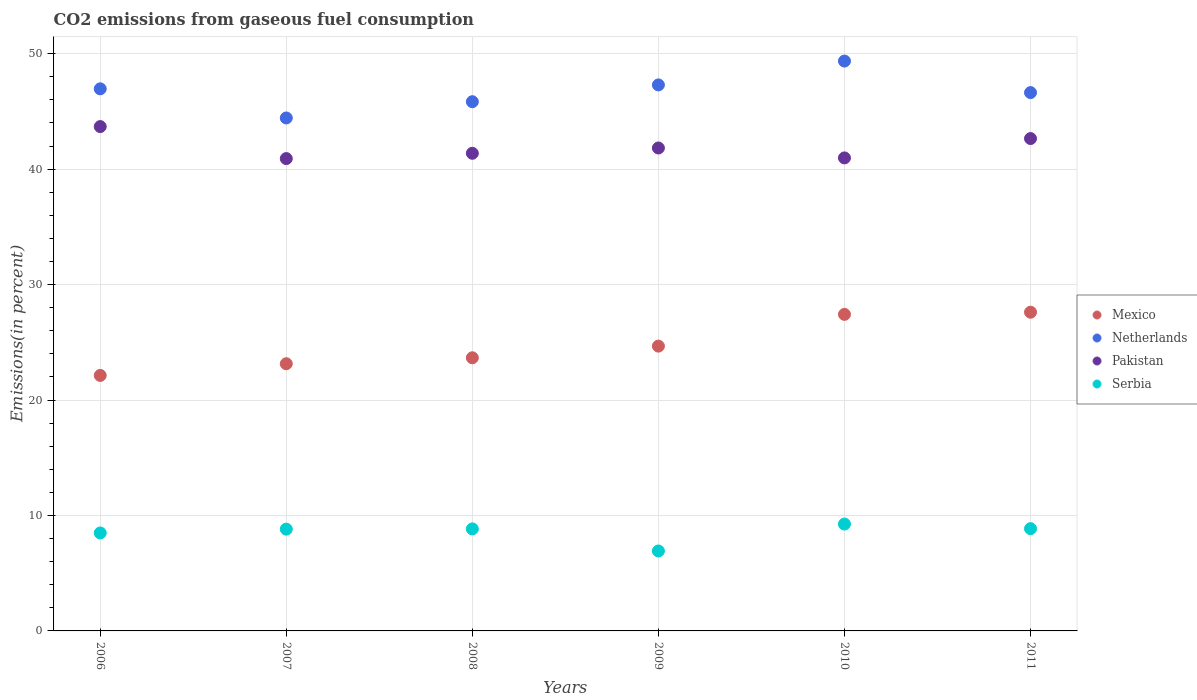How many different coloured dotlines are there?
Give a very brief answer. 4. Is the number of dotlines equal to the number of legend labels?
Ensure brevity in your answer.  Yes. What is the total CO2 emitted in Mexico in 2010?
Provide a short and direct response. 27.42. Across all years, what is the maximum total CO2 emitted in Serbia?
Your answer should be very brief. 9.26. Across all years, what is the minimum total CO2 emitted in Serbia?
Your answer should be compact. 6.92. What is the total total CO2 emitted in Netherlands in the graph?
Make the answer very short. 280.49. What is the difference between the total CO2 emitted in Mexico in 2007 and that in 2009?
Give a very brief answer. -1.53. What is the difference between the total CO2 emitted in Netherlands in 2006 and the total CO2 emitted in Serbia in 2008?
Keep it short and to the point. 38.12. What is the average total CO2 emitted in Netherlands per year?
Your answer should be very brief. 46.75. In the year 2008, what is the difference between the total CO2 emitted in Mexico and total CO2 emitted in Pakistan?
Make the answer very short. -17.71. What is the ratio of the total CO2 emitted in Netherlands in 2007 to that in 2008?
Provide a short and direct response. 0.97. Is the total CO2 emitted in Mexico in 2010 less than that in 2011?
Make the answer very short. Yes. Is the difference between the total CO2 emitted in Mexico in 2009 and 2011 greater than the difference between the total CO2 emitted in Pakistan in 2009 and 2011?
Provide a succinct answer. No. What is the difference between the highest and the second highest total CO2 emitted in Serbia?
Keep it short and to the point. 0.4. What is the difference between the highest and the lowest total CO2 emitted in Pakistan?
Offer a terse response. 2.77. Is it the case that in every year, the sum of the total CO2 emitted in Mexico and total CO2 emitted in Pakistan  is greater than the sum of total CO2 emitted in Netherlands and total CO2 emitted in Serbia?
Offer a very short reply. No. Is it the case that in every year, the sum of the total CO2 emitted in Pakistan and total CO2 emitted in Netherlands  is greater than the total CO2 emitted in Mexico?
Offer a terse response. Yes. Is the total CO2 emitted in Netherlands strictly greater than the total CO2 emitted in Pakistan over the years?
Ensure brevity in your answer.  Yes. Is the total CO2 emitted in Mexico strictly less than the total CO2 emitted in Pakistan over the years?
Your response must be concise. Yes. How many years are there in the graph?
Your answer should be compact. 6. Are the values on the major ticks of Y-axis written in scientific E-notation?
Provide a succinct answer. No. Does the graph contain any zero values?
Keep it short and to the point. No. Does the graph contain grids?
Your response must be concise. Yes. Where does the legend appear in the graph?
Offer a terse response. Center right. How many legend labels are there?
Offer a very short reply. 4. What is the title of the graph?
Your answer should be compact. CO2 emissions from gaseous fuel consumption. What is the label or title of the X-axis?
Provide a succinct answer. Years. What is the label or title of the Y-axis?
Give a very brief answer. Emissions(in percent). What is the Emissions(in percent) in Mexico in 2006?
Make the answer very short. 22.13. What is the Emissions(in percent) of Netherlands in 2006?
Your answer should be compact. 46.95. What is the Emissions(in percent) in Pakistan in 2006?
Your answer should be very brief. 43.68. What is the Emissions(in percent) in Serbia in 2006?
Your answer should be very brief. 8.48. What is the Emissions(in percent) of Mexico in 2007?
Keep it short and to the point. 23.14. What is the Emissions(in percent) in Netherlands in 2007?
Offer a very short reply. 44.43. What is the Emissions(in percent) of Pakistan in 2007?
Your answer should be very brief. 40.91. What is the Emissions(in percent) of Serbia in 2007?
Provide a short and direct response. 8.81. What is the Emissions(in percent) in Mexico in 2008?
Ensure brevity in your answer.  23.66. What is the Emissions(in percent) in Netherlands in 2008?
Provide a succinct answer. 45.84. What is the Emissions(in percent) in Pakistan in 2008?
Keep it short and to the point. 41.37. What is the Emissions(in percent) in Serbia in 2008?
Provide a succinct answer. 8.84. What is the Emissions(in percent) of Mexico in 2009?
Ensure brevity in your answer.  24.67. What is the Emissions(in percent) in Netherlands in 2009?
Keep it short and to the point. 47.29. What is the Emissions(in percent) of Pakistan in 2009?
Ensure brevity in your answer.  41.83. What is the Emissions(in percent) of Serbia in 2009?
Ensure brevity in your answer.  6.92. What is the Emissions(in percent) in Mexico in 2010?
Offer a terse response. 27.42. What is the Emissions(in percent) in Netherlands in 2010?
Make the answer very short. 49.36. What is the Emissions(in percent) in Pakistan in 2010?
Provide a short and direct response. 40.97. What is the Emissions(in percent) of Serbia in 2010?
Keep it short and to the point. 9.26. What is the Emissions(in percent) of Mexico in 2011?
Provide a short and direct response. 27.61. What is the Emissions(in percent) in Netherlands in 2011?
Ensure brevity in your answer.  46.63. What is the Emissions(in percent) of Pakistan in 2011?
Your answer should be very brief. 42.65. What is the Emissions(in percent) in Serbia in 2011?
Your answer should be compact. 8.86. Across all years, what is the maximum Emissions(in percent) in Mexico?
Offer a terse response. 27.61. Across all years, what is the maximum Emissions(in percent) of Netherlands?
Keep it short and to the point. 49.36. Across all years, what is the maximum Emissions(in percent) in Pakistan?
Provide a succinct answer. 43.68. Across all years, what is the maximum Emissions(in percent) in Serbia?
Provide a short and direct response. 9.26. Across all years, what is the minimum Emissions(in percent) in Mexico?
Offer a terse response. 22.13. Across all years, what is the minimum Emissions(in percent) in Netherlands?
Offer a very short reply. 44.43. Across all years, what is the minimum Emissions(in percent) of Pakistan?
Give a very brief answer. 40.91. Across all years, what is the minimum Emissions(in percent) of Serbia?
Offer a terse response. 6.92. What is the total Emissions(in percent) in Mexico in the graph?
Provide a short and direct response. 148.62. What is the total Emissions(in percent) in Netherlands in the graph?
Give a very brief answer. 280.49. What is the total Emissions(in percent) of Pakistan in the graph?
Your response must be concise. 251.41. What is the total Emissions(in percent) of Serbia in the graph?
Give a very brief answer. 51.17. What is the difference between the Emissions(in percent) in Mexico in 2006 and that in 2007?
Ensure brevity in your answer.  -1.01. What is the difference between the Emissions(in percent) of Netherlands in 2006 and that in 2007?
Make the answer very short. 2.52. What is the difference between the Emissions(in percent) in Pakistan in 2006 and that in 2007?
Provide a succinct answer. 2.77. What is the difference between the Emissions(in percent) in Serbia in 2006 and that in 2007?
Your answer should be compact. -0.33. What is the difference between the Emissions(in percent) of Mexico in 2006 and that in 2008?
Your response must be concise. -1.53. What is the difference between the Emissions(in percent) in Netherlands in 2006 and that in 2008?
Your response must be concise. 1.12. What is the difference between the Emissions(in percent) of Pakistan in 2006 and that in 2008?
Your answer should be compact. 2.31. What is the difference between the Emissions(in percent) in Serbia in 2006 and that in 2008?
Make the answer very short. -0.35. What is the difference between the Emissions(in percent) of Mexico in 2006 and that in 2009?
Your response must be concise. -2.54. What is the difference between the Emissions(in percent) in Netherlands in 2006 and that in 2009?
Your answer should be very brief. -0.34. What is the difference between the Emissions(in percent) of Pakistan in 2006 and that in 2009?
Keep it short and to the point. 1.85. What is the difference between the Emissions(in percent) of Serbia in 2006 and that in 2009?
Keep it short and to the point. 1.56. What is the difference between the Emissions(in percent) in Mexico in 2006 and that in 2010?
Make the answer very short. -5.29. What is the difference between the Emissions(in percent) of Netherlands in 2006 and that in 2010?
Your answer should be compact. -2.4. What is the difference between the Emissions(in percent) of Pakistan in 2006 and that in 2010?
Provide a succinct answer. 2.71. What is the difference between the Emissions(in percent) of Serbia in 2006 and that in 2010?
Provide a short and direct response. -0.77. What is the difference between the Emissions(in percent) in Mexico in 2006 and that in 2011?
Your answer should be compact. -5.48. What is the difference between the Emissions(in percent) in Netherlands in 2006 and that in 2011?
Your answer should be very brief. 0.33. What is the difference between the Emissions(in percent) of Pakistan in 2006 and that in 2011?
Your answer should be very brief. 1.04. What is the difference between the Emissions(in percent) of Serbia in 2006 and that in 2011?
Ensure brevity in your answer.  -0.37. What is the difference between the Emissions(in percent) in Mexico in 2007 and that in 2008?
Provide a short and direct response. -0.52. What is the difference between the Emissions(in percent) of Netherlands in 2007 and that in 2008?
Provide a succinct answer. -1.41. What is the difference between the Emissions(in percent) of Pakistan in 2007 and that in 2008?
Provide a succinct answer. -0.46. What is the difference between the Emissions(in percent) of Serbia in 2007 and that in 2008?
Your answer should be very brief. -0.02. What is the difference between the Emissions(in percent) of Mexico in 2007 and that in 2009?
Make the answer very short. -1.53. What is the difference between the Emissions(in percent) in Netherlands in 2007 and that in 2009?
Keep it short and to the point. -2.86. What is the difference between the Emissions(in percent) in Pakistan in 2007 and that in 2009?
Your response must be concise. -0.92. What is the difference between the Emissions(in percent) in Serbia in 2007 and that in 2009?
Ensure brevity in your answer.  1.89. What is the difference between the Emissions(in percent) of Mexico in 2007 and that in 2010?
Provide a short and direct response. -4.28. What is the difference between the Emissions(in percent) in Netherlands in 2007 and that in 2010?
Your response must be concise. -4.93. What is the difference between the Emissions(in percent) of Pakistan in 2007 and that in 2010?
Give a very brief answer. -0.06. What is the difference between the Emissions(in percent) in Serbia in 2007 and that in 2010?
Provide a succinct answer. -0.44. What is the difference between the Emissions(in percent) in Mexico in 2007 and that in 2011?
Keep it short and to the point. -4.46. What is the difference between the Emissions(in percent) in Netherlands in 2007 and that in 2011?
Make the answer very short. -2.2. What is the difference between the Emissions(in percent) of Pakistan in 2007 and that in 2011?
Your answer should be compact. -1.74. What is the difference between the Emissions(in percent) in Serbia in 2007 and that in 2011?
Offer a terse response. -0.04. What is the difference between the Emissions(in percent) in Mexico in 2008 and that in 2009?
Offer a terse response. -1.01. What is the difference between the Emissions(in percent) of Netherlands in 2008 and that in 2009?
Offer a very short reply. -1.45. What is the difference between the Emissions(in percent) of Pakistan in 2008 and that in 2009?
Offer a terse response. -0.46. What is the difference between the Emissions(in percent) in Serbia in 2008 and that in 2009?
Your response must be concise. 1.91. What is the difference between the Emissions(in percent) in Mexico in 2008 and that in 2010?
Your answer should be compact. -3.76. What is the difference between the Emissions(in percent) of Netherlands in 2008 and that in 2010?
Your response must be concise. -3.52. What is the difference between the Emissions(in percent) of Pakistan in 2008 and that in 2010?
Your answer should be very brief. 0.4. What is the difference between the Emissions(in percent) in Serbia in 2008 and that in 2010?
Provide a succinct answer. -0.42. What is the difference between the Emissions(in percent) of Mexico in 2008 and that in 2011?
Your response must be concise. -3.95. What is the difference between the Emissions(in percent) of Netherlands in 2008 and that in 2011?
Ensure brevity in your answer.  -0.79. What is the difference between the Emissions(in percent) of Pakistan in 2008 and that in 2011?
Your answer should be very brief. -1.28. What is the difference between the Emissions(in percent) in Serbia in 2008 and that in 2011?
Offer a very short reply. -0.02. What is the difference between the Emissions(in percent) of Mexico in 2009 and that in 2010?
Your answer should be very brief. -2.75. What is the difference between the Emissions(in percent) in Netherlands in 2009 and that in 2010?
Make the answer very short. -2.07. What is the difference between the Emissions(in percent) of Pakistan in 2009 and that in 2010?
Provide a short and direct response. 0.86. What is the difference between the Emissions(in percent) of Serbia in 2009 and that in 2010?
Your response must be concise. -2.33. What is the difference between the Emissions(in percent) in Mexico in 2009 and that in 2011?
Your response must be concise. -2.94. What is the difference between the Emissions(in percent) in Netherlands in 2009 and that in 2011?
Your response must be concise. 0.67. What is the difference between the Emissions(in percent) in Pakistan in 2009 and that in 2011?
Ensure brevity in your answer.  -0.82. What is the difference between the Emissions(in percent) in Serbia in 2009 and that in 2011?
Provide a short and direct response. -1.93. What is the difference between the Emissions(in percent) in Mexico in 2010 and that in 2011?
Give a very brief answer. -0.19. What is the difference between the Emissions(in percent) in Netherlands in 2010 and that in 2011?
Keep it short and to the point. 2.73. What is the difference between the Emissions(in percent) of Pakistan in 2010 and that in 2011?
Ensure brevity in your answer.  -1.68. What is the difference between the Emissions(in percent) in Serbia in 2010 and that in 2011?
Offer a very short reply. 0.4. What is the difference between the Emissions(in percent) of Mexico in 2006 and the Emissions(in percent) of Netherlands in 2007?
Offer a terse response. -22.3. What is the difference between the Emissions(in percent) in Mexico in 2006 and the Emissions(in percent) in Pakistan in 2007?
Your answer should be very brief. -18.78. What is the difference between the Emissions(in percent) of Mexico in 2006 and the Emissions(in percent) of Serbia in 2007?
Provide a short and direct response. 13.31. What is the difference between the Emissions(in percent) of Netherlands in 2006 and the Emissions(in percent) of Pakistan in 2007?
Your answer should be very brief. 6.04. What is the difference between the Emissions(in percent) of Netherlands in 2006 and the Emissions(in percent) of Serbia in 2007?
Ensure brevity in your answer.  38.14. What is the difference between the Emissions(in percent) of Pakistan in 2006 and the Emissions(in percent) of Serbia in 2007?
Your answer should be compact. 34.87. What is the difference between the Emissions(in percent) in Mexico in 2006 and the Emissions(in percent) in Netherlands in 2008?
Offer a very short reply. -23.71. What is the difference between the Emissions(in percent) of Mexico in 2006 and the Emissions(in percent) of Pakistan in 2008?
Provide a succinct answer. -19.24. What is the difference between the Emissions(in percent) in Mexico in 2006 and the Emissions(in percent) in Serbia in 2008?
Provide a succinct answer. 13.29. What is the difference between the Emissions(in percent) in Netherlands in 2006 and the Emissions(in percent) in Pakistan in 2008?
Ensure brevity in your answer.  5.58. What is the difference between the Emissions(in percent) in Netherlands in 2006 and the Emissions(in percent) in Serbia in 2008?
Offer a terse response. 38.12. What is the difference between the Emissions(in percent) in Pakistan in 2006 and the Emissions(in percent) in Serbia in 2008?
Offer a terse response. 34.85. What is the difference between the Emissions(in percent) in Mexico in 2006 and the Emissions(in percent) in Netherlands in 2009?
Ensure brevity in your answer.  -25.16. What is the difference between the Emissions(in percent) of Mexico in 2006 and the Emissions(in percent) of Pakistan in 2009?
Offer a terse response. -19.7. What is the difference between the Emissions(in percent) of Mexico in 2006 and the Emissions(in percent) of Serbia in 2009?
Your answer should be compact. 15.2. What is the difference between the Emissions(in percent) of Netherlands in 2006 and the Emissions(in percent) of Pakistan in 2009?
Provide a succinct answer. 5.13. What is the difference between the Emissions(in percent) of Netherlands in 2006 and the Emissions(in percent) of Serbia in 2009?
Your answer should be very brief. 40.03. What is the difference between the Emissions(in percent) in Pakistan in 2006 and the Emissions(in percent) in Serbia in 2009?
Your answer should be very brief. 36.76. What is the difference between the Emissions(in percent) of Mexico in 2006 and the Emissions(in percent) of Netherlands in 2010?
Ensure brevity in your answer.  -27.23. What is the difference between the Emissions(in percent) in Mexico in 2006 and the Emissions(in percent) in Pakistan in 2010?
Make the answer very short. -18.84. What is the difference between the Emissions(in percent) in Mexico in 2006 and the Emissions(in percent) in Serbia in 2010?
Make the answer very short. 12.87. What is the difference between the Emissions(in percent) in Netherlands in 2006 and the Emissions(in percent) in Pakistan in 2010?
Provide a succinct answer. 5.98. What is the difference between the Emissions(in percent) of Netherlands in 2006 and the Emissions(in percent) of Serbia in 2010?
Give a very brief answer. 37.7. What is the difference between the Emissions(in percent) in Pakistan in 2006 and the Emissions(in percent) in Serbia in 2010?
Offer a very short reply. 34.43. What is the difference between the Emissions(in percent) in Mexico in 2006 and the Emissions(in percent) in Netherlands in 2011?
Offer a very short reply. -24.5. What is the difference between the Emissions(in percent) in Mexico in 2006 and the Emissions(in percent) in Pakistan in 2011?
Provide a short and direct response. -20.52. What is the difference between the Emissions(in percent) in Mexico in 2006 and the Emissions(in percent) in Serbia in 2011?
Give a very brief answer. 13.27. What is the difference between the Emissions(in percent) in Netherlands in 2006 and the Emissions(in percent) in Pakistan in 2011?
Offer a terse response. 4.31. What is the difference between the Emissions(in percent) of Netherlands in 2006 and the Emissions(in percent) of Serbia in 2011?
Give a very brief answer. 38.1. What is the difference between the Emissions(in percent) in Pakistan in 2006 and the Emissions(in percent) in Serbia in 2011?
Provide a short and direct response. 34.83. What is the difference between the Emissions(in percent) of Mexico in 2007 and the Emissions(in percent) of Netherlands in 2008?
Provide a succinct answer. -22.7. What is the difference between the Emissions(in percent) of Mexico in 2007 and the Emissions(in percent) of Pakistan in 2008?
Your answer should be compact. -18.23. What is the difference between the Emissions(in percent) of Mexico in 2007 and the Emissions(in percent) of Serbia in 2008?
Keep it short and to the point. 14.31. What is the difference between the Emissions(in percent) in Netherlands in 2007 and the Emissions(in percent) in Pakistan in 2008?
Provide a short and direct response. 3.06. What is the difference between the Emissions(in percent) of Netherlands in 2007 and the Emissions(in percent) of Serbia in 2008?
Your response must be concise. 35.59. What is the difference between the Emissions(in percent) of Pakistan in 2007 and the Emissions(in percent) of Serbia in 2008?
Offer a very short reply. 32.08. What is the difference between the Emissions(in percent) of Mexico in 2007 and the Emissions(in percent) of Netherlands in 2009?
Provide a succinct answer. -24.15. What is the difference between the Emissions(in percent) in Mexico in 2007 and the Emissions(in percent) in Pakistan in 2009?
Keep it short and to the point. -18.69. What is the difference between the Emissions(in percent) in Mexico in 2007 and the Emissions(in percent) in Serbia in 2009?
Make the answer very short. 16.22. What is the difference between the Emissions(in percent) of Netherlands in 2007 and the Emissions(in percent) of Pakistan in 2009?
Your answer should be very brief. 2.6. What is the difference between the Emissions(in percent) in Netherlands in 2007 and the Emissions(in percent) in Serbia in 2009?
Provide a succinct answer. 37.51. What is the difference between the Emissions(in percent) in Pakistan in 2007 and the Emissions(in percent) in Serbia in 2009?
Offer a very short reply. 33.99. What is the difference between the Emissions(in percent) in Mexico in 2007 and the Emissions(in percent) in Netherlands in 2010?
Your answer should be very brief. -26.22. What is the difference between the Emissions(in percent) of Mexico in 2007 and the Emissions(in percent) of Pakistan in 2010?
Keep it short and to the point. -17.83. What is the difference between the Emissions(in percent) in Mexico in 2007 and the Emissions(in percent) in Serbia in 2010?
Offer a terse response. 13.89. What is the difference between the Emissions(in percent) in Netherlands in 2007 and the Emissions(in percent) in Pakistan in 2010?
Offer a very short reply. 3.46. What is the difference between the Emissions(in percent) in Netherlands in 2007 and the Emissions(in percent) in Serbia in 2010?
Keep it short and to the point. 35.17. What is the difference between the Emissions(in percent) of Pakistan in 2007 and the Emissions(in percent) of Serbia in 2010?
Provide a succinct answer. 31.65. What is the difference between the Emissions(in percent) in Mexico in 2007 and the Emissions(in percent) in Netherlands in 2011?
Provide a succinct answer. -23.48. What is the difference between the Emissions(in percent) in Mexico in 2007 and the Emissions(in percent) in Pakistan in 2011?
Keep it short and to the point. -19.5. What is the difference between the Emissions(in percent) in Mexico in 2007 and the Emissions(in percent) in Serbia in 2011?
Offer a terse response. 14.28. What is the difference between the Emissions(in percent) of Netherlands in 2007 and the Emissions(in percent) of Pakistan in 2011?
Your answer should be compact. 1.78. What is the difference between the Emissions(in percent) in Netherlands in 2007 and the Emissions(in percent) in Serbia in 2011?
Keep it short and to the point. 35.57. What is the difference between the Emissions(in percent) of Pakistan in 2007 and the Emissions(in percent) of Serbia in 2011?
Make the answer very short. 32.05. What is the difference between the Emissions(in percent) of Mexico in 2008 and the Emissions(in percent) of Netherlands in 2009?
Make the answer very short. -23.63. What is the difference between the Emissions(in percent) of Mexico in 2008 and the Emissions(in percent) of Pakistan in 2009?
Provide a short and direct response. -18.17. What is the difference between the Emissions(in percent) in Mexico in 2008 and the Emissions(in percent) in Serbia in 2009?
Make the answer very short. 16.73. What is the difference between the Emissions(in percent) of Netherlands in 2008 and the Emissions(in percent) of Pakistan in 2009?
Keep it short and to the point. 4.01. What is the difference between the Emissions(in percent) in Netherlands in 2008 and the Emissions(in percent) in Serbia in 2009?
Ensure brevity in your answer.  38.91. What is the difference between the Emissions(in percent) in Pakistan in 2008 and the Emissions(in percent) in Serbia in 2009?
Make the answer very short. 34.45. What is the difference between the Emissions(in percent) of Mexico in 2008 and the Emissions(in percent) of Netherlands in 2010?
Provide a short and direct response. -25.7. What is the difference between the Emissions(in percent) of Mexico in 2008 and the Emissions(in percent) of Pakistan in 2010?
Give a very brief answer. -17.31. What is the difference between the Emissions(in percent) of Mexico in 2008 and the Emissions(in percent) of Serbia in 2010?
Provide a succinct answer. 14.4. What is the difference between the Emissions(in percent) of Netherlands in 2008 and the Emissions(in percent) of Pakistan in 2010?
Ensure brevity in your answer.  4.87. What is the difference between the Emissions(in percent) of Netherlands in 2008 and the Emissions(in percent) of Serbia in 2010?
Your answer should be compact. 36.58. What is the difference between the Emissions(in percent) in Pakistan in 2008 and the Emissions(in percent) in Serbia in 2010?
Give a very brief answer. 32.11. What is the difference between the Emissions(in percent) in Mexico in 2008 and the Emissions(in percent) in Netherlands in 2011?
Provide a short and direct response. -22.97. What is the difference between the Emissions(in percent) in Mexico in 2008 and the Emissions(in percent) in Pakistan in 2011?
Your answer should be very brief. -18.99. What is the difference between the Emissions(in percent) of Mexico in 2008 and the Emissions(in percent) of Serbia in 2011?
Provide a short and direct response. 14.8. What is the difference between the Emissions(in percent) of Netherlands in 2008 and the Emissions(in percent) of Pakistan in 2011?
Your answer should be compact. 3.19. What is the difference between the Emissions(in percent) of Netherlands in 2008 and the Emissions(in percent) of Serbia in 2011?
Your answer should be compact. 36.98. What is the difference between the Emissions(in percent) of Pakistan in 2008 and the Emissions(in percent) of Serbia in 2011?
Ensure brevity in your answer.  32.51. What is the difference between the Emissions(in percent) in Mexico in 2009 and the Emissions(in percent) in Netherlands in 2010?
Your answer should be compact. -24.69. What is the difference between the Emissions(in percent) of Mexico in 2009 and the Emissions(in percent) of Pakistan in 2010?
Make the answer very short. -16.3. What is the difference between the Emissions(in percent) of Mexico in 2009 and the Emissions(in percent) of Serbia in 2010?
Make the answer very short. 15.41. What is the difference between the Emissions(in percent) of Netherlands in 2009 and the Emissions(in percent) of Pakistan in 2010?
Keep it short and to the point. 6.32. What is the difference between the Emissions(in percent) of Netherlands in 2009 and the Emissions(in percent) of Serbia in 2010?
Keep it short and to the point. 38.04. What is the difference between the Emissions(in percent) in Pakistan in 2009 and the Emissions(in percent) in Serbia in 2010?
Offer a terse response. 32.57. What is the difference between the Emissions(in percent) in Mexico in 2009 and the Emissions(in percent) in Netherlands in 2011?
Keep it short and to the point. -21.96. What is the difference between the Emissions(in percent) of Mexico in 2009 and the Emissions(in percent) of Pakistan in 2011?
Provide a short and direct response. -17.98. What is the difference between the Emissions(in percent) of Mexico in 2009 and the Emissions(in percent) of Serbia in 2011?
Ensure brevity in your answer.  15.81. What is the difference between the Emissions(in percent) in Netherlands in 2009 and the Emissions(in percent) in Pakistan in 2011?
Provide a succinct answer. 4.65. What is the difference between the Emissions(in percent) of Netherlands in 2009 and the Emissions(in percent) of Serbia in 2011?
Your answer should be compact. 38.43. What is the difference between the Emissions(in percent) in Pakistan in 2009 and the Emissions(in percent) in Serbia in 2011?
Give a very brief answer. 32.97. What is the difference between the Emissions(in percent) of Mexico in 2010 and the Emissions(in percent) of Netherlands in 2011?
Your answer should be very brief. -19.21. What is the difference between the Emissions(in percent) in Mexico in 2010 and the Emissions(in percent) in Pakistan in 2011?
Provide a short and direct response. -15.23. What is the difference between the Emissions(in percent) of Mexico in 2010 and the Emissions(in percent) of Serbia in 2011?
Offer a terse response. 18.56. What is the difference between the Emissions(in percent) of Netherlands in 2010 and the Emissions(in percent) of Pakistan in 2011?
Provide a succinct answer. 6.71. What is the difference between the Emissions(in percent) of Netherlands in 2010 and the Emissions(in percent) of Serbia in 2011?
Offer a terse response. 40.5. What is the difference between the Emissions(in percent) in Pakistan in 2010 and the Emissions(in percent) in Serbia in 2011?
Your answer should be very brief. 32.11. What is the average Emissions(in percent) of Mexico per year?
Your answer should be very brief. 24.77. What is the average Emissions(in percent) of Netherlands per year?
Offer a terse response. 46.75. What is the average Emissions(in percent) of Pakistan per year?
Offer a terse response. 41.9. What is the average Emissions(in percent) of Serbia per year?
Your answer should be compact. 8.53. In the year 2006, what is the difference between the Emissions(in percent) of Mexico and Emissions(in percent) of Netherlands?
Ensure brevity in your answer.  -24.82. In the year 2006, what is the difference between the Emissions(in percent) in Mexico and Emissions(in percent) in Pakistan?
Offer a very short reply. -21.55. In the year 2006, what is the difference between the Emissions(in percent) of Mexico and Emissions(in percent) of Serbia?
Your answer should be very brief. 13.64. In the year 2006, what is the difference between the Emissions(in percent) of Netherlands and Emissions(in percent) of Pakistan?
Provide a succinct answer. 3.27. In the year 2006, what is the difference between the Emissions(in percent) of Netherlands and Emissions(in percent) of Serbia?
Your response must be concise. 38.47. In the year 2006, what is the difference between the Emissions(in percent) of Pakistan and Emissions(in percent) of Serbia?
Offer a very short reply. 35.2. In the year 2007, what is the difference between the Emissions(in percent) of Mexico and Emissions(in percent) of Netherlands?
Provide a succinct answer. -21.29. In the year 2007, what is the difference between the Emissions(in percent) of Mexico and Emissions(in percent) of Pakistan?
Offer a very short reply. -17.77. In the year 2007, what is the difference between the Emissions(in percent) in Mexico and Emissions(in percent) in Serbia?
Ensure brevity in your answer.  14.33. In the year 2007, what is the difference between the Emissions(in percent) of Netherlands and Emissions(in percent) of Pakistan?
Provide a short and direct response. 3.52. In the year 2007, what is the difference between the Emissions(in percent) in Netherlands and Emissions(in percent) in Serbia?
Your response must be concise. 35.62. In the year 2007, what is the difference between the Emissions(in percent) of Pakistan and Emissions(in percent) of Serbia?
Keep it short and to the point. 32.1. In the year 2008, what is the difference between the Emissions(in percent) of Mexico and Emissions(in percent) of Netherlands?
Offer a terse response. -22.18. In the year 2008, what is the difference between the Emissions(in percent) of Mexico and Emissions(in percent) of Pakistan?
Provide a short and direct response. -17.71. In the year 2008, what is the difference between the Emissions(in percent) in Mexico and Emissions(in percent) in Serbia?
Your response must be concise. 14.82. In the year 2008, what is the difference between the Emissions(in percent) of Netherlands and Emissions(in percent) of Pakistan?
Ensure brevity in your answer.  4.47. In the year 2008, what is the difference between the Emissions(in percent) of Netherlands and Emissions(in percent) of Serbia?
Offer a terse response. 37. In the year 2008, what is the difference between the Emissions(in percent) of Pakistan and Emissions(in percent) of Serbia?
Ensure brevity in your answer.  32.54. In the year 2009, what is the difference between the Emissions(in percent) of Mexico and Emissions(in percent) of Netherlands?
Your answer should be very brief. -22.62. In the year 2009, what is the difference between the Emissions(in percent) of Mexico and Emissions(in percent) of Pakistan?
Offer a terse response. -17.16. In the year 2009, what is the difference between the Emissions(in percent) in Mexico and Emissions(in percent) in Serbia?
Make the answer very short. 17.74. In the year 2009, what is the difference between the Emissions(in percent) of Netherlands and Emissions(in percent) of Pakistan?
Provide a short and direct response. 5.46. In the year 2009, what is the difference between the Emissions(in percent) in Netherlands and Emissions(in percent) in Serbia?
Ensure brevity in your answer.  40.37. In the year 2009, what is the difference between the Emissions(in percent) of Pakistan and Emissions(in percent) of Serbia?
Provide a succinct answer. 34.9. In the year 2010, what is the difference between the Emissions(in percent) in Mexico and Emissions(in percent) in Netherlands?
Your answer should be very brief. -21.94. In the year 2010, what is the difference between the Emissions(in percent) of Mexico and Emissions(in percent) of Pakistan?
Your response must be concise. -13.55. In the year 2010, what is the difference between the Emissions(in percent) of Mexico and Emissions(in percent) of Serbia?
Offer a very short reply. 18.16. In the year 2010, what is the difference between the Emissions(in percent) of Netherlands and Emissions(in percent) of Pakistan?
Ensure brevity in your answer.  8.39. In the year 2010, what is the difference between the Emissions(in percent) in Netherlands and Emissions(in percent) in Serbia?
Your response must be concise. 40.1. In the year 2010, what is the difference between the Emissions(in percent) of Pakistan and Emissions(in percent) of Serbia?
Give a very brief answer. 31.71. In the year 2011, what is the difference between the Emissions(in percent) of Mexico and Emissions(in percent) of Netherlands?
Offer a very short reply. -19.02. In the year 2011, what is the difference between the Emissions(in percent) in Mexico and Emissions(in percent) in Pakistan?
Offer a very short reply. -15.04. In the year 2011, what is the difference between the Emissions(in percent) in Mexico and Emissions(in percent) in Serbia?
Your response must be concise. 18.75. In the year 2011, what is the difference between the Emissions(in percent) in Netherlands and Emissions(in percent) in Pakistan?
Your answer should be very brief. 3.98. In the year 2011, what is the difference between the Emissions(in percent) of Netherlands and Emissions(in percent) of Serbia?
Provide a short and direct response. 37.77. In the year 2011, what is the difference between the Emissions(in percent) of Pakistan and Emissions(in percent) of Serbia?
Provide a short and direct response. 33.79. What is the ratio of the Emissions(in percent) of Mexico in 2006 to that in 2007?
Provide a succinct answer. 0.96. What is the ratio of the Emissions(in percent) of Netherlands in 2006 to that in 2007?
Provide a succinct answer. 1.06. What is the ratio of the Emissions(in percent) in Pakistan in 2006 to that in 2007?
Your answer should be very brief. 1.07. What is the ratio of the Emissions(in percent) in Serbia in 2006 to that in 2007?
Provide a succinct answer. 0.96. What is the ratio of the Emissions(in percent) in Mexico in 2006 to that in 2008?
Make the answer very short. 0.94. What is the ratio of the Emissions(in percent) of Netherlands in 2006 to that in 2008?
Your answer should be compact. 1.02. What is the ratio of the Emissions(in percent) of Pakistan in 2006 to that in 2008?
Give a very brief answer. 1.06. What is the ratio of the Emissions(in percent) in Serbia in 2006 to that in 2008?
Your response must be concise. 0.96. What is the ratio of the Emissions(in percent) of Mexico in 2006 to that in 2009?
Provide a short and direct response. 0.9. What is the ratio of the Emissions(in percent) of Netherlands in 2006 to that in 2009?
Provide a short and direct response. 0.99. What is the ratio of the Emissions(in percent) in Pakistan in 2006 to that in 2009?
Your response must be concise. 1.04. What is the ratio of the Emissions(in percent) of Serbia in 2006 to that in 2009?
Your answer should be compact. 1.23. What is the ratio of the Emissions(in percent) of Mexico in 2006 to that in 2010?
Your answer should be compact. 0.81. What is the ratio of the Emissions(in percent) of Netherlands in 2006 to that in 2010?
Provide a short and direct response. 0.95. What is the ratio of the Emissions(in percent) of Pakistan in 2006 to that in 2010?
Keep it short and to the point. 1.07. What is the ratio of the Emissions(in percent) of Mexico in 2006 to that in 2011?
Your response must be concise. 0.8. What is the ratio of the Emissions(in percent) in Pakistan in 2006 to that in 2011?
Offer a very short reply. 1.02. What is the ratio of the Emissions(in percent) of Serbia in 2006 to that in 2011?
Provide a succinct answer. 0.96. What is the ratio of the Emissions(in percent) in Mexico in 2007 to that in 2008?
Offer a terse response. 0.98. What is the ratio of the Emissions(in percent) in Netherlands in 2007 to that in 2008?
Give a very brief answer. 0.97. What is the ratio of the Emissions(in percent) in Pakistan in 2007 to that in 2008?
Your answer should be compact. 0.99. What is the ratio of the Emissions(in percent) of Serbia in 2007 to that in 2008?
Your answer should be compact. 1. What is the ratio of the Emissions(in percent) of Mexico in 2007 to that in 2009?
Ensure brevity in your answer.  0.94. What is the ratio of the Emissions(in percent) of Netherlands in 2007 to that in 2009?
Provide a short and direct response. 0.94. What is the ratio of the Emissions(in percent) in Pakistan in 2007 to that in 2009?
Provide a succinct answer. 0.98. What is the ratio of the Emissions(in percent) in Serbia in 2007 to that in 2009?
Provide a short and direct response. 1.27. What is the ratio of the Emissions(in percent) in Mexico in 2007 to that in 2010?
Make the answer very short. 0.84. What is the ratio of the Emissions(in percent) of Netherlands in 2007 to that in 2010?
Keep it short and to the point. 0.9. What is the ratio of the Emissions(in percent) of Serbia in 2007 to that in 2010?
Provide a succinct answer. 0.95. What is the ratio of the Emissions(in percent) in Mexico in 2007 to that in 2011?
Ensure brevity in your answer.  0.84. What is the ratio of the Emissions(in percent) in Netherlands in 2007 to that in 2011?
Keep it short and to the point. 0.95. What is the ratio of the Emissions(in percent) in Pakistan in 2007 to that in 2011?
Give a very brief answer. 0.96. What is the ratio of the Emissions(in percent) of Mexico in 2008 to that in 2009?
Your answer should be compact. 0.96. What is the ratio of the Emissions(in percent) in Netherlands in 2008 to that in 2009?
Keep it short and to the point. 0.97. What is the ratio of the Emissions(in percent) of Serbia in 2008 to that in 2009?
Your answer should be very brief. 1.28. What is the ratio of the Emissions(in percent) in Mexico in 2008 to that in 2010?
Provide a succinct answer. 0.86. What is the ratio of the Emissions(in percent) of Netherlands in 2008 to that in 2010?
Your response must be concise. 0.93. What is the ratio of the Emissions(in percent) of Pakistan in 2008 to that in 2010?
Your response must be concise. 1.01. What is the ratio of the Emissions(in percent) in Serbia in 2008 to that in 2010?
Your answer should be very brief. 0.95. What is the ratio of the Emissions(in percent) in Mexico in 2008 to that in 2011?
Your answer should be very brief. 0.86. What is the ratio of the Emissions(in percent) of Netherlands in 2008 to that in 2011?
Keep it short and to the point. 0.98. What is the ratio of the Emissions(in percent) in Pakistan in 2008 to that in 2011?
Make the answer very short. 0.97. What is the ratio of the Emissions(in percent) of Mexico in 2009 to that in 2010?
Offer a terse response. 0.9. What is the ratio of the Emissions(in percent) in Netherlands in 2009 to that in 2010?
Offer a very short reply. 0.96. What is the ratio of the Emissions(in percent) of Serbia in 2009 to that in 2010?
Make the answer very short. 0.75. What is the ratio of the Emissions(in percent) in Mexico in 2009 to that in 2011?
Provide a short and direct response. 0.89. What is the ratio of the Emissions(in percent) in Netherlands in 2009 to that in 2011?
Your response must be concise. 1.01. What is the ratio of the Emissions(in percent) of Pakistan in 2009 to that in 2011?
Offer a terse response. 0.98. What is the ratio of the Emissions(in percent) of Serbia in 2009 to that in 2011?
Offer a very short reply. 0.78. What is the ratio of the Emissions(in percent) in Netherlands in 2010 to that in 2011?
Keep it short and to the point. 1.06. What is the ratio of the Emissions(in percent) in Pakistan in 2010 to that in 2011?
Provide a short and direct response. 0.96. What is the ratio of the Emissions(in percent) in Serbia in 2010 to that in 2011?
Your answer should be compact. 1.04. What is the difference between the highest and the second highest Emissions(in percent) in Mexico?
Offer a very short reply. 0.19. What is the difference between the highest and the second highest Emissions(in percent) of Netherlands?
Ensure brevity in your answer.  2.07. What is the difference between the highest and the second highest Emissions(in percent) in Pakistan?
Your answer should be very brief. 1.04. What is the difference between the highest and the second highest Emissions(in percent) of Serbia?
Provide a short and direct response. 0.4. What is the difference between the highest and the lowest Emissions(in percent) of Mexico?
Provide a short and direct response. 5.48. What is the difference between the highest and the lowest Emissions(in percent) of Netherlands?
Ensure brevity in your answer.  4.93. What is the difference between the highest and the lowest Emissions(in percent) in Pakistan?
Offer a very short reply. 2.77. What is the difference between the highest and the lowest Emissions(in percent) in Serbia?
Give a very brief answer. 2.33. 